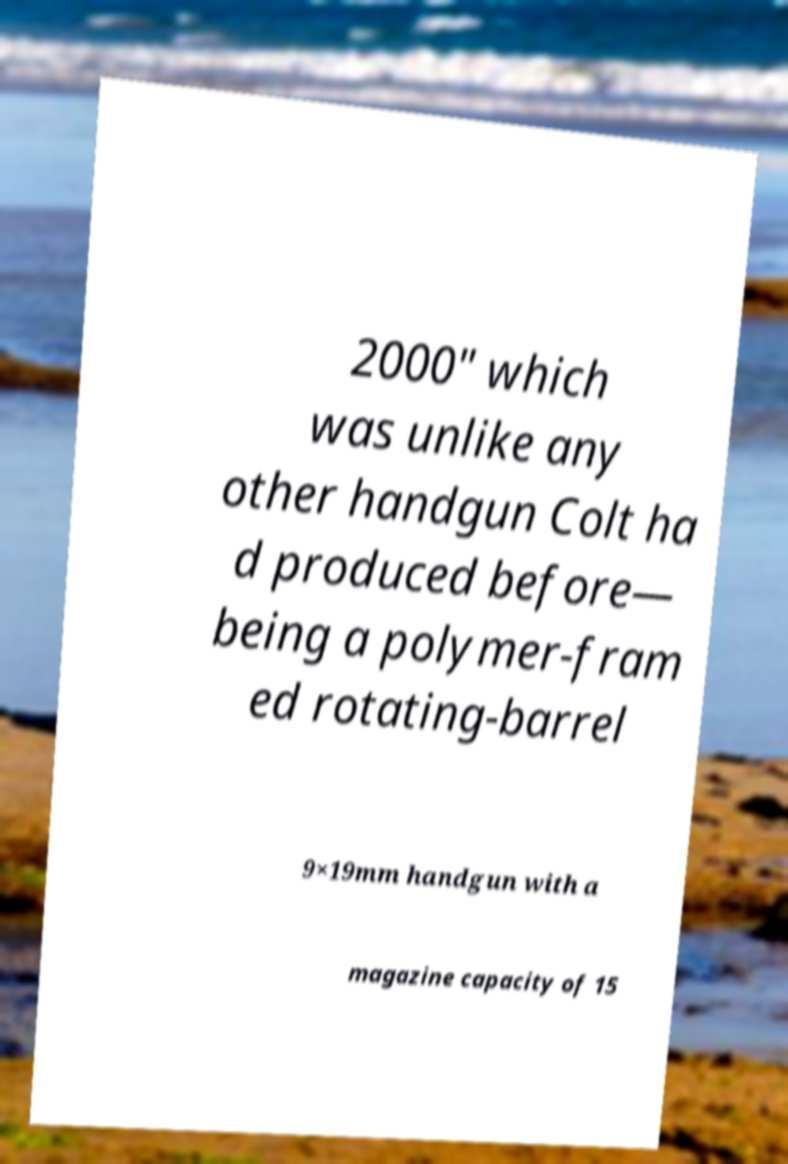There's text embedded in this image that I need extracted. Can you transcribe it verbatim? 2000" which was unlike any other handgun Colt ha d produced before— being a polymer-fram ed rotating-barrel 9×19mm handgun with a magazine capacity of 15 